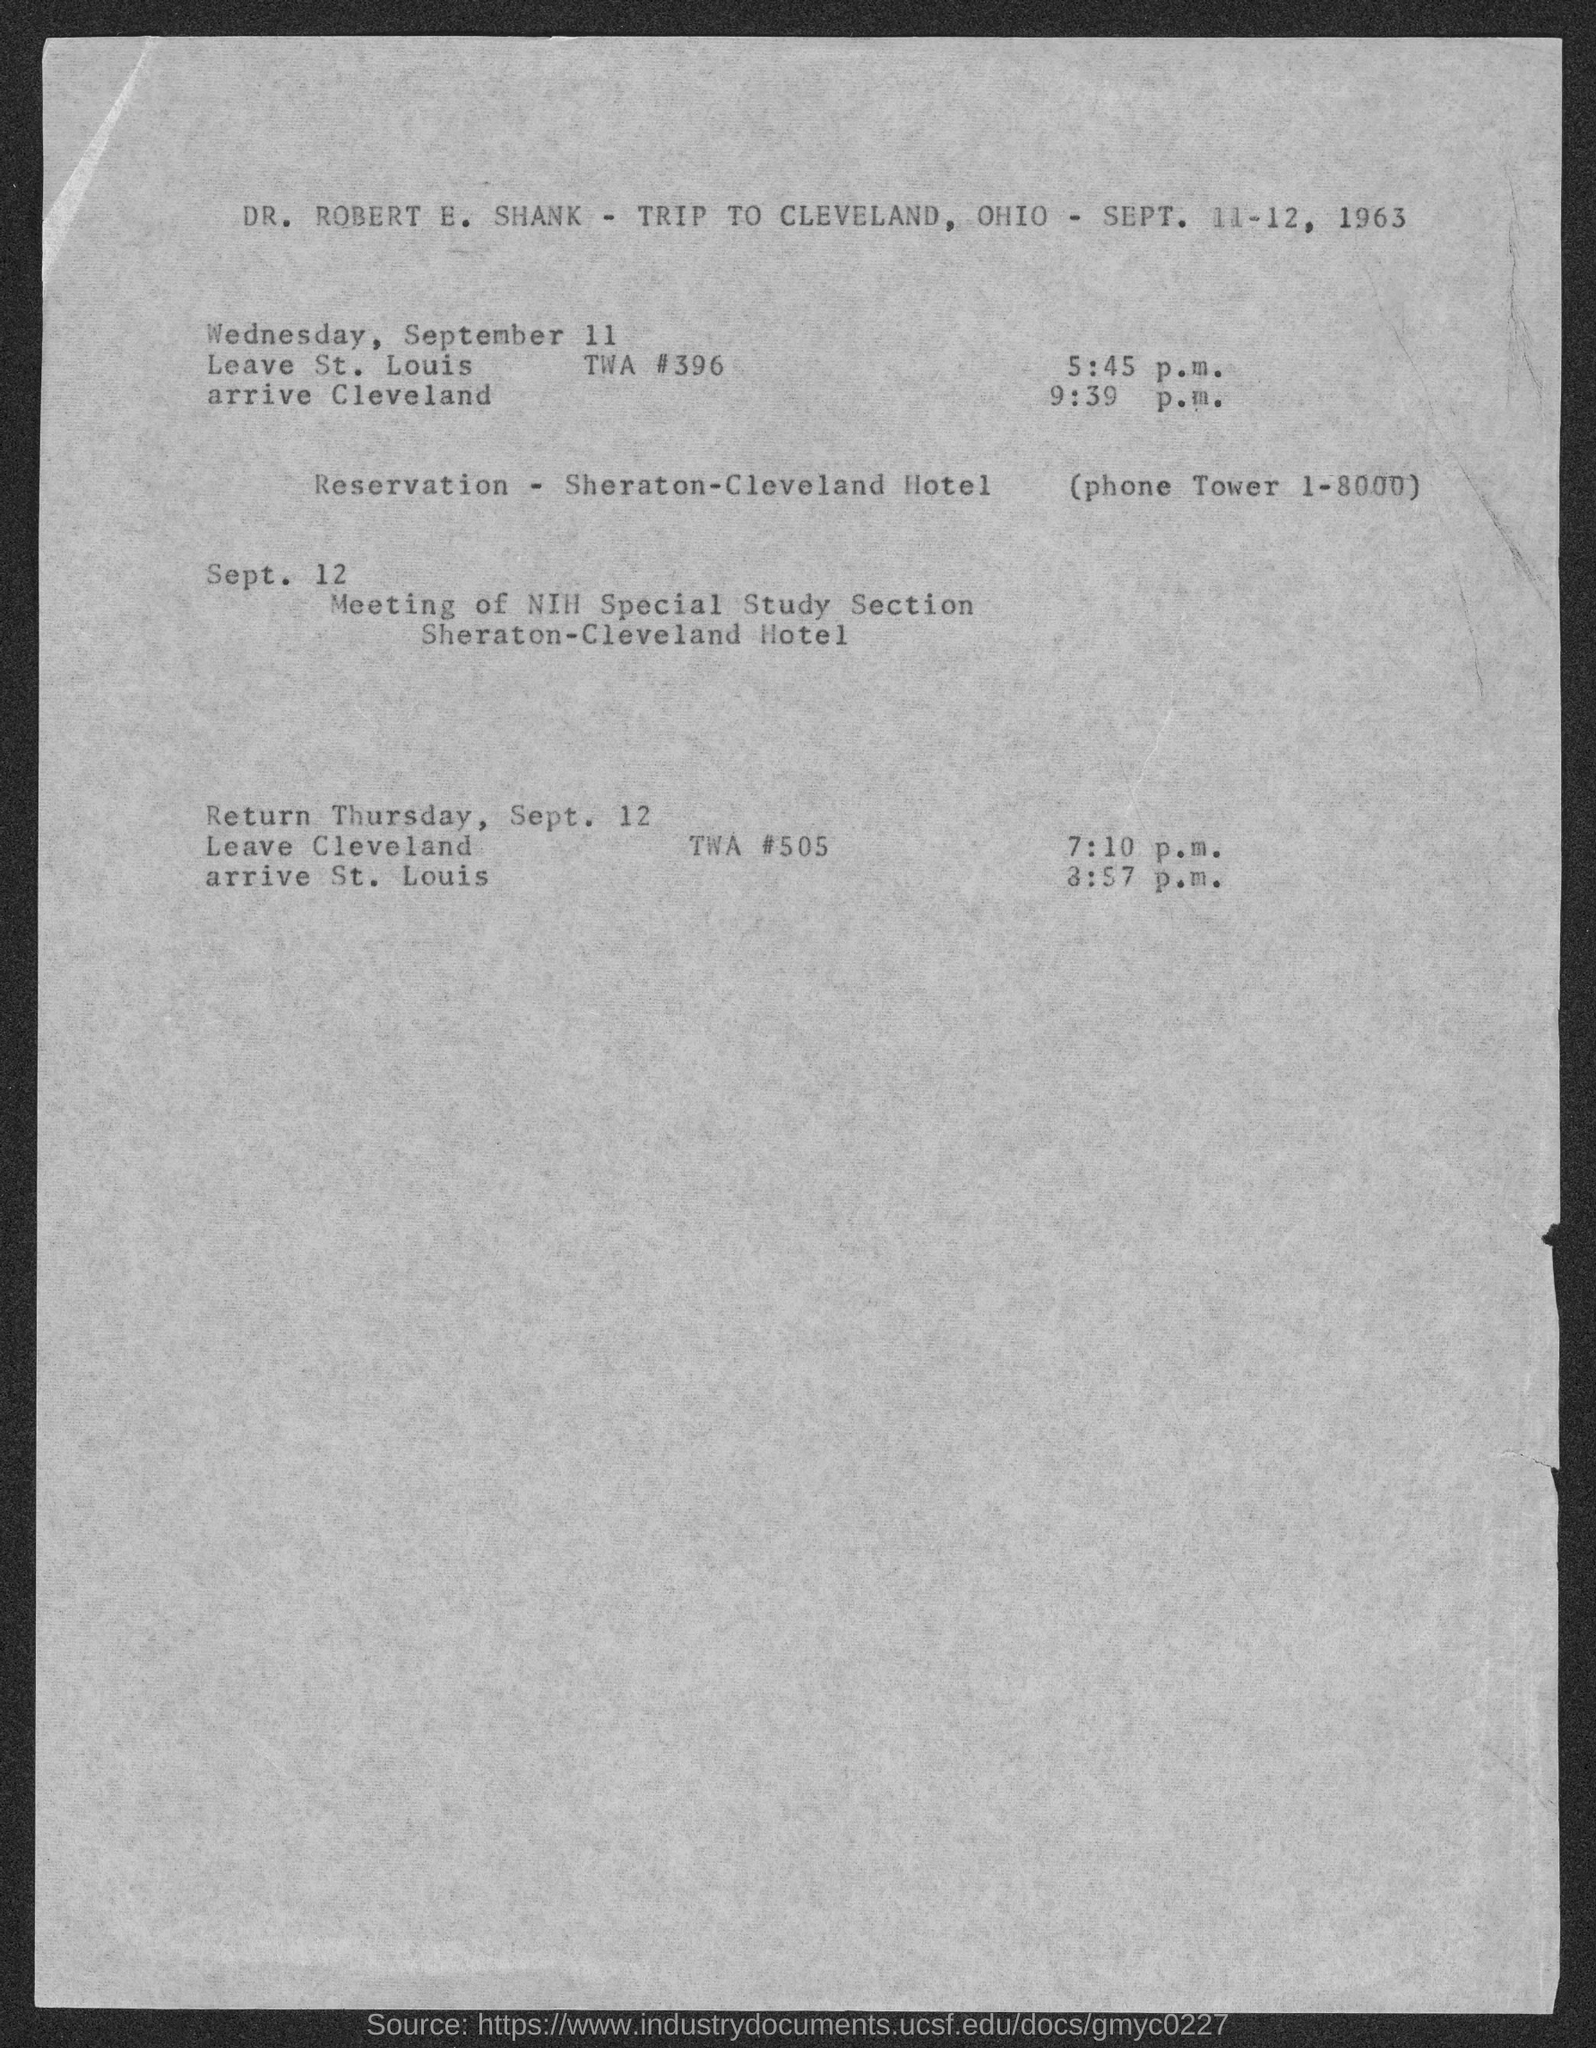Draw attention to some important aspects in this diagram. Dr. Robert E. Shank is having a meeting with the NIH Special Study Section on September 12th. DR. ROBERT E. SHANK is expected to return from Cleveland on Thursday, September 12th. Robert E. Shank is embarking on a journey to Cleveland, Ohio. The phone Tower number is 1-8000. DR. ROBERT E. SHANK will reach Cleveland at 9:39 p.m. 